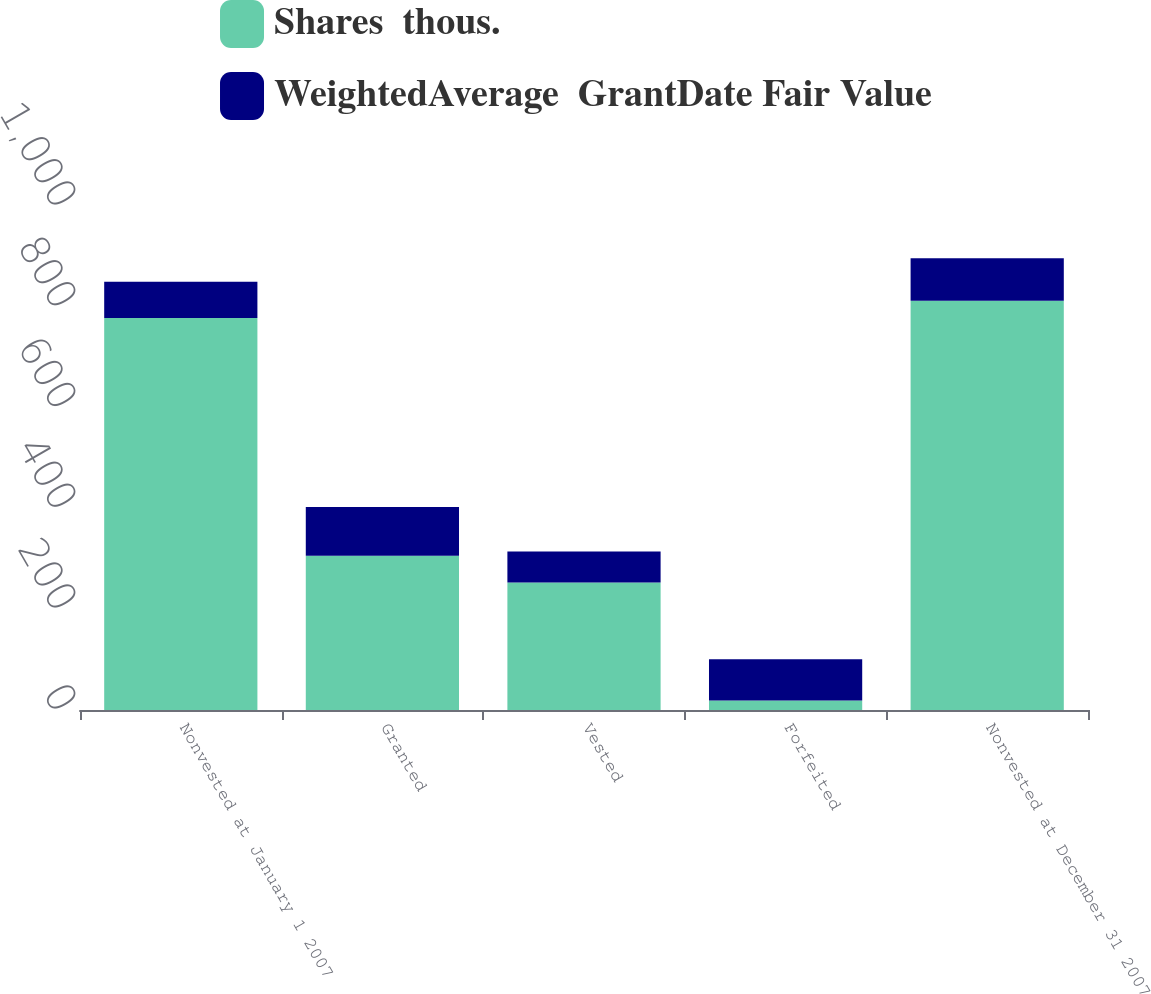Convert chart. <chart><loc_0><loc_0><loc_500><loc_500><stacked_bar_chart><ecel><fcel>Nonvested at January 1 2007<fcel>Granted<fcel>Vested<fcel>Forfeited<fcel>Nonvested at December 31 2007<nl><fcel>Shares  thous.<fcel>778<fcel>306<fcel>253<fcel>19<fcel>812<nl><fcel>WeightedAverage  GrantDate Fair Value<fcel>71.72<fcel>97.01<fcel>61.66<fcel>81.8<fcel>84.09<nl></chart> 